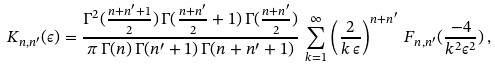<formula> <loc_0><loc_0><loc_500><loc_500>K _ { n , n ^ { \prime } } ( \epsilon ) = \frac { \Gamma ^ { 2 } ( \frac { n + n ^ { \prime } + 1 } { 2 } ) \, \Gamma ( \frac { n + n ^ { \prime } } { 2 } + 1 ) \, \Gamma ( \frac { n + n ^ { \prime } } { 2 } ) } { \pi \, \Gamma ( n ) \, \Gamma ( n ^ { \prime } + 1 ) \, \Gamma ( n + n ^ { \prime } + 1 ) } \, \sum _ { k = 1 } ^ { \infty } \left ( \frac { 2 } { k \, \epsilon } \right ) ^ { n + n ^ { \prime } } \, F _ { n , n ^ { \prime } } ( \frac { - 4 } { k ^ { 2 } \epsilon ^ { 2 } } ) \, ,</formula> 